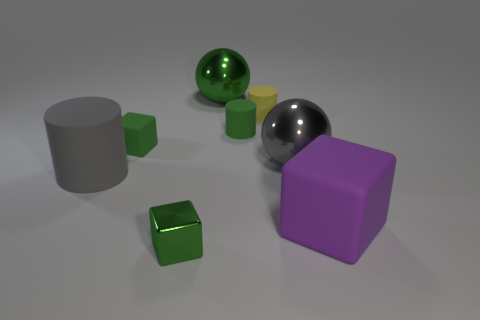Subtract all blue spheres. Subtract all blue blocks. How many spheres are left? 2 Add 1 large red things. How many objects exist? 9 Subtract all cylinders. How many objects are left? 5 Add 1 large matte cylinders. How many large matte cylinders exist? 2 Subtract 0 purple cylinders. How many objects are left? 8 Subtract all cyan metal cylinders. Subtract all yellow matte objects. How many objects are left? 7 Add 1 green metallic things. How many green metallic things are left? 3 